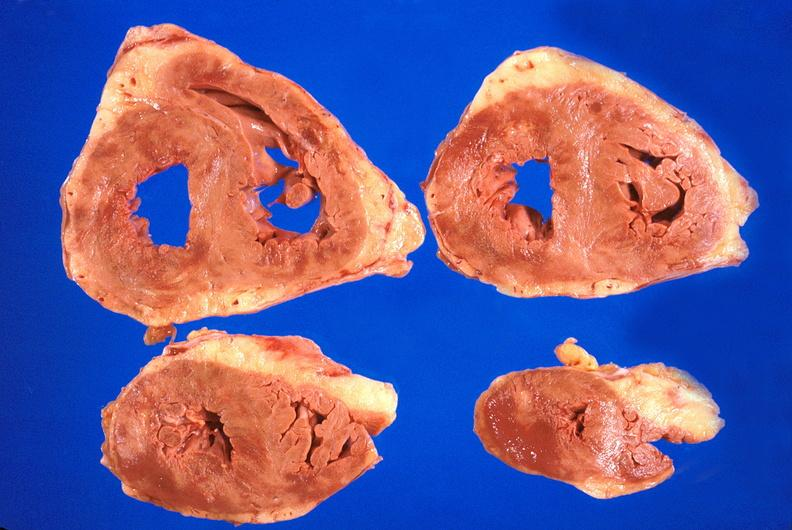what does this image show?
Answer the question using a single word or phrase. Heart 